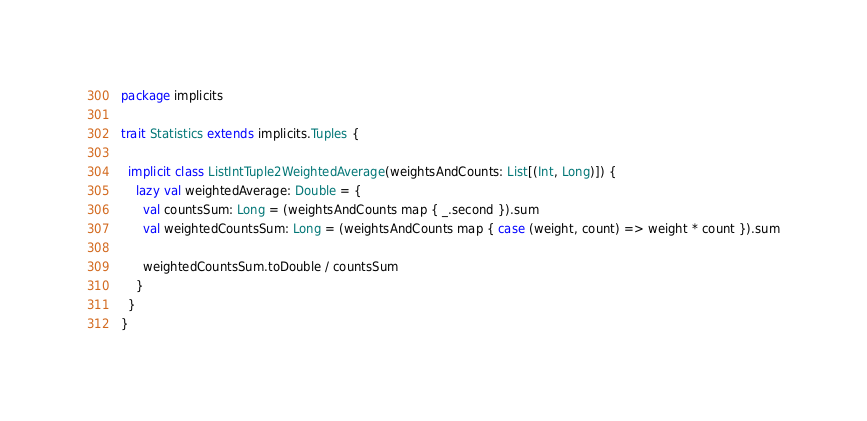<code> <loc_0><loc_0><loc_500><loc_500><_Scala_>package implicits

trait Statistics extends implicits.Tuples {

  implicit class ListIntTuple2WeightedAverage(weightsAndCounts: List[(Int, Long)]) {
    lazy val weightedAverage: Double = {
      val countsSum: Long = (weightsAndCounts map { _.second }).sum
      val weightedCountsSum: Long = (weightsAndCounts map { case (weight, count) => weight * count }).sum

      weightedCountsSum.toDouble / countsSum
    }
  }
}
</code> 